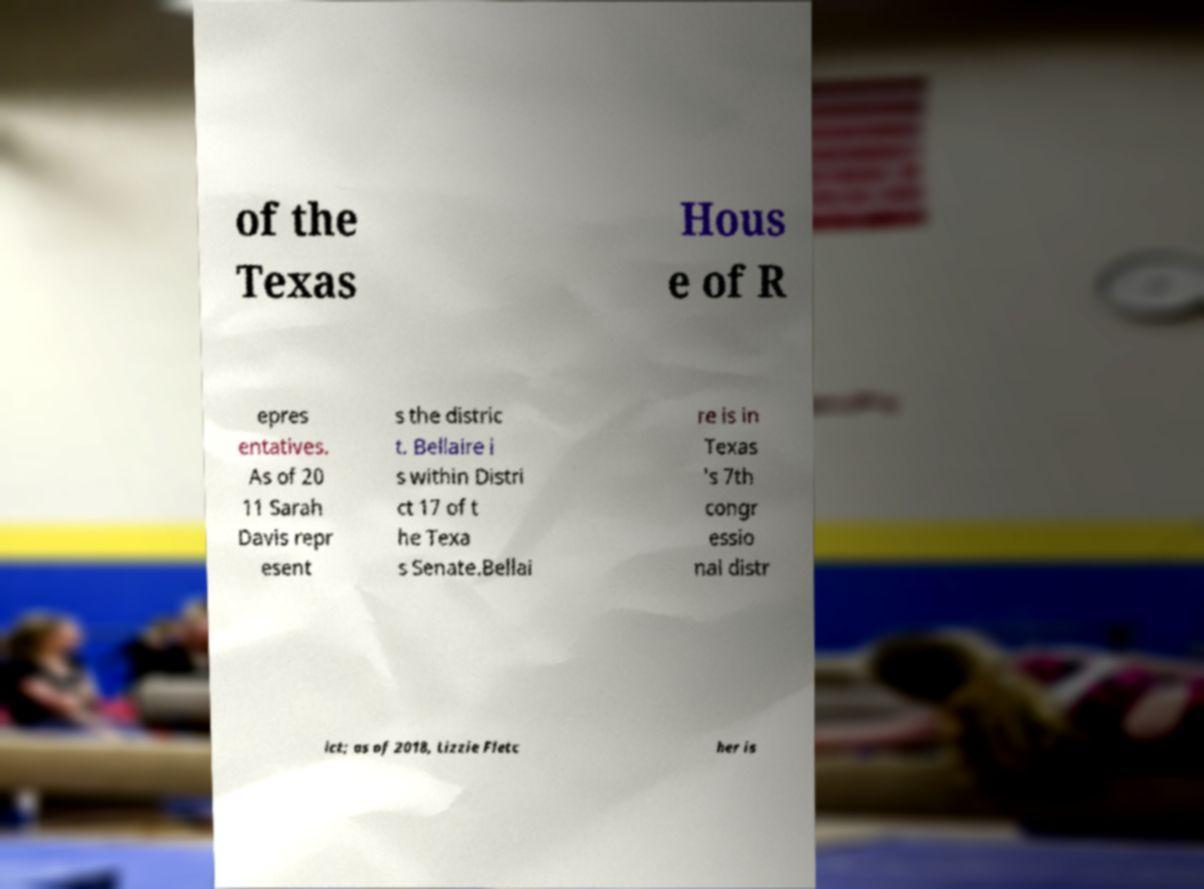What messages or text are displayed in this image? I need them in a readable, typed format. of the Texas Hous e of R epres entatives. As of 20 11 Sarah Davis repr esent s the distric t. Bellaire i s within Distri ct 17 of t he Texa s Senate.Bellai re is in Texas 's 7th congr essio nal distr ict; as of 2018, Lizzie Fletc her is 